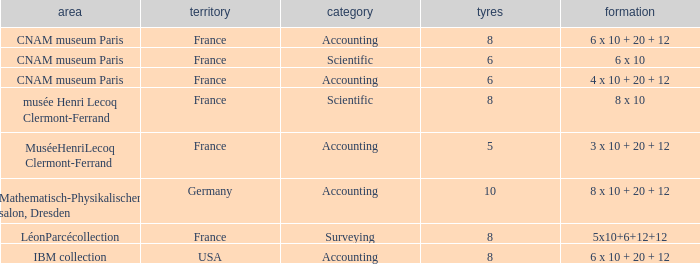What location has surveying as the type? LéonParcécollection. 